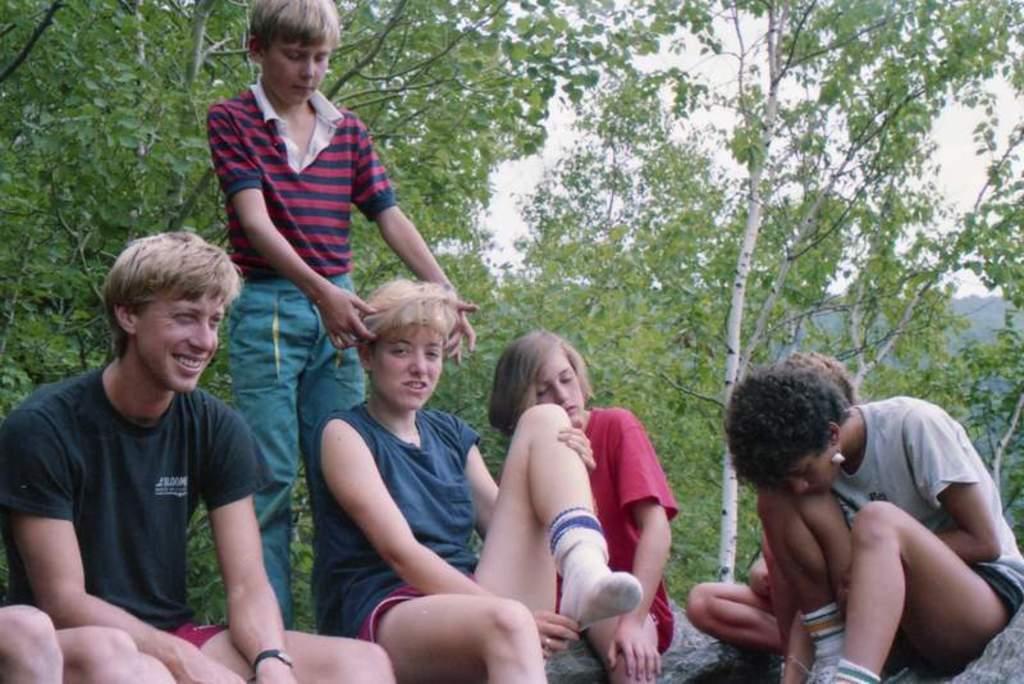Could you give a brief overview of what you see in this image? In the picture I can see people among them one boy is standing and others are sitting on the ground. In the background I can see the sky and trees. 